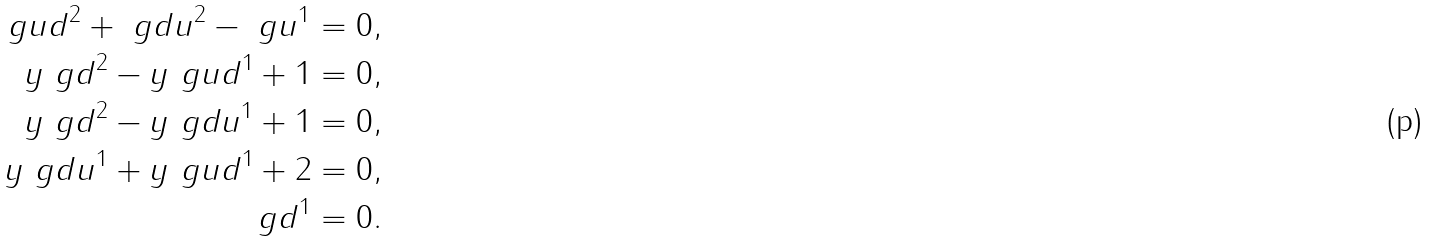<formula> <loc_0><loc_0><loc_500><loc_500>\ g u d ^ { 2 } + \ g d u ^ { 2 } - \ g u ^ { 1 } & = 0 , \\ y \ g d ^ { 2 } - y \ g u d ^ { 1 } + 1 & = 0 , \\ y \ g d ^ { 2 } - y \ g d u ^ { 1 } + 1 & = 0 , \\ y \ g d u ^ { 1 } + y \ g u d ^ { 1 } + 2 & = 0 , \\ \ g d ^ { 1 } & = 0 .</formula> 